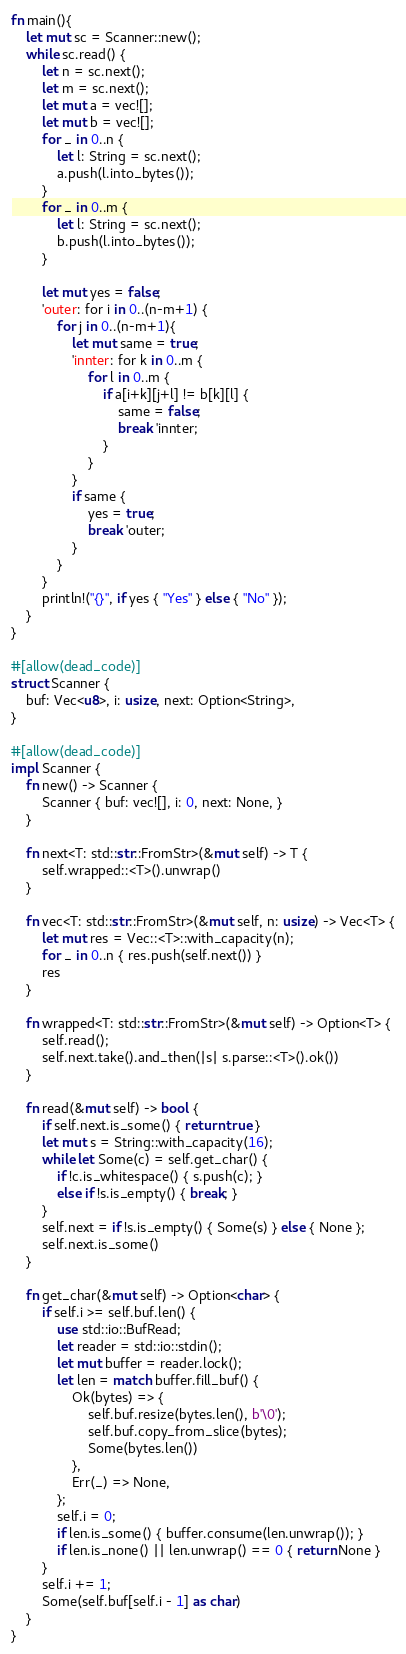<code> <loc_0><loc_0><loc_500><loc_500><_Rust_>fn main(){
    let mut sc = Scanner::new();
    while sc.read() {
        let n = sc.next();
        let m = sc.next();
        let mut a = vec![];
        let mut b = vec![];
        for _ in 0..n {
            let l: String = sc.next();
            a.push(l.into_bytes());
        }
        for _ in 0..m {
            let l: String = sc.next();
            b.push(l.into_bytes());
        }

        let mut yes = false;
        'outer: for i in 0..(n-m+1) {
            for j in 0..(n-m+1){
                let mut same = true;
                'innter: for k in 0..m {
                    for l in 0..m {
                        if a[i+k][j+l] != b[k][l] {
                            same = false;
                            break 'innter;
                        }
                    }
                }
                if same {
                    yes = true;
                    break 'outer;
                }
            }
        }
        println!("{}", if yes { "Yes" } else { "No" });
    }
}

#[allow(dead_code)]
struct Scanner {
    buf: Vec<u8>, i: usize, next: Option<String>,
}

#[allow(dead_code)]
impl Scanner {
    fn new() -> Scanner {
        Scanner { buf: vec![], i: 0, next: None, }
    }

    fn next<T: std::str::FromStr>(&mut self) -> T {
        self.wrapped::<T>().unwrap()
    }

    fn vec<T: std::str::FromStr>(&mut self, n: usize) -> Vec<T> {
        let mut res = Vec::<T>::with_capacity(n);
        for _ in 0..n { res.push(self.next()) }
        res
    }

    fn wrapped<T: std::str::FromStr>(&mut self) -> Option<T> {
        self.read();
        self.next.take().and_then(|s| s.parse::<T>().ok())
    }

    fn read(&mut self) -> bool {
        if self.next.is_some() { return true }
        let mut s = String::with_capacity(16);
        while let Some(c) = self.get_char() {
            if !c.is_whitespace() { s.push(c); }
            else if !s.is_empty() { break; }
        }
        self.next = if !s.is_empty() { Some(s) } else { None };
        self.next.is_some()
    }

    fn get_char(&mut self) -> Option<char> {
        if self.i >= self.buf.len() {
            use std::io::BufRead;
            let reader = std::io::stdin();
            let mut buffer = reader.lock();
            let len = match buffer.fill_buf() {
                Ok(bytes) => {
                    self.buf.resize(bytes.len(), b'\0');
                    self.buf.copy_from_slice(bytes);
                    Some(bytes.len())
                },
                Err(_) => None,
            };
            self.i = 0;
            if len.is_some() { buffer.consume(len.unwrap()); }
            if len.is_none() || len.unwrap() == 0 { return None }
        }
        self.i += 1;
        Some(self.buf[self.i - 1] as char)
    }
}
</code> 